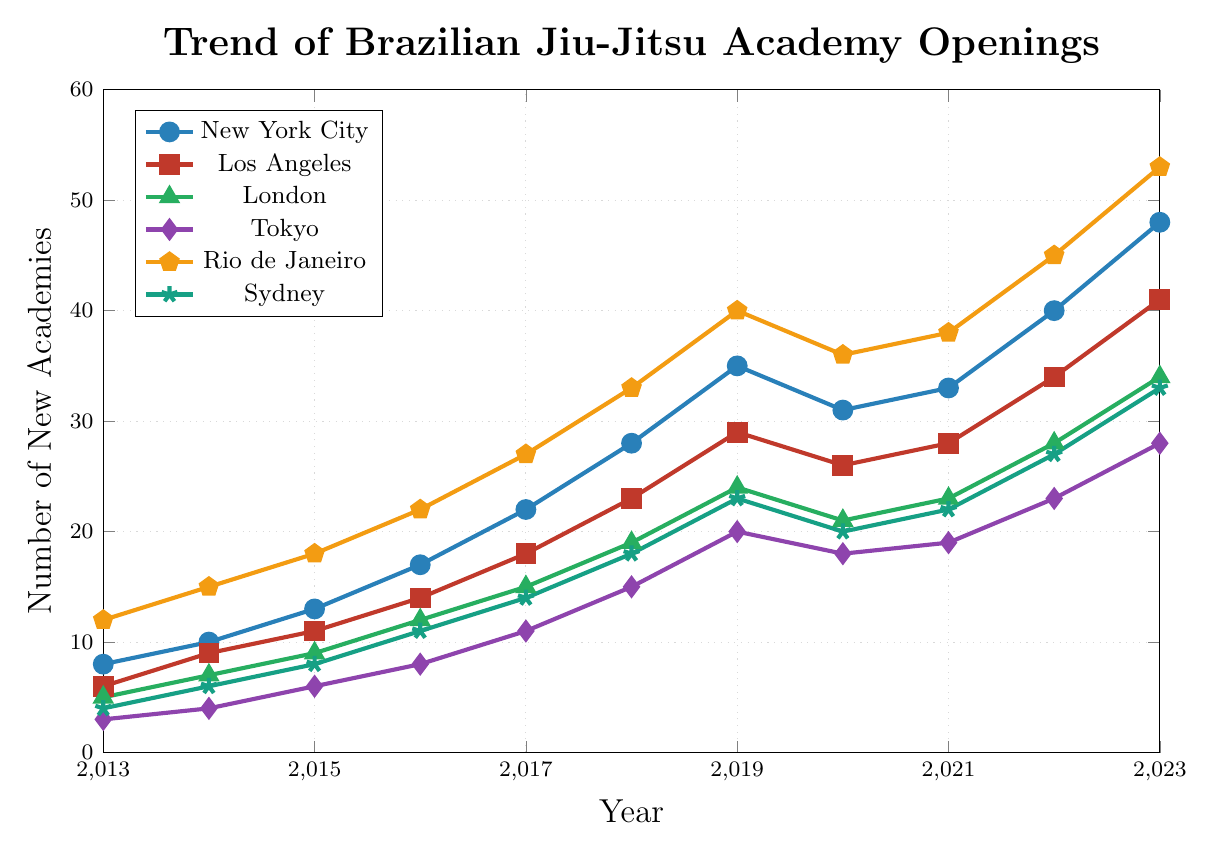Which city saw the highest number of new Brazilian Jiu-Jitsu academies opened in 2023? Look at the highest data point for each city in 2023. Rio de Janeiro has a value of 53 new academies, which is the highest among all the cities.
Answer: Rio de Janeiro Between 2019 and 2020, which city experienced a decrease in the number of new academies? Examine the data points between 2019 and 2020 for each city. New York City, Los Angeles, Tokyo, Rio de Janeiro, and Sydney show a decline.
Answer: New York City, Los Angeles, Tokyo, Rio de Janeiro, Sydney What is the average number of new academies opened in Tokyo from 2013 to 2023? To find the average, sum all the data points for Tokyo from 2013 to 2023 and divide by the number of years. (3+4+6+8+11+15+20+18+19+23+28) / 11 = 155 / 11 = 14.09 (rounded to two decimal places)
Answer: 14.09 Which city had the largest increase in the number of new academies from 2013 to 2023? Calculate the difference between the starting (2013) and ending (2023) values for each city. The largest difference is for Rio de Janeiro with 53 - 12 = 41.
Answer: Rio de Janeiro How many more new academies were opened in Rio de Janeiro compared to Sydney in 2023? Subtract the number of new academies in Sydney from the number in Rio de Janeiro in 2023. 53 - 33 = 20
Answer: 20 In which year did New York City see its sharpest increase in the number of new academies? Compare the year-over-year increments for New York City and identify the year with the highest increase. From 2018 to 2019, the increase was 35 - 28 = 7, which is the sharpest increase.
Answer: 2019 Which two cities had the same number of new academies opened in any given year? Compare the data points for each pair of cities across all years. New York City and Rio de Janeiro both had 36 new academies in 2020.
Answer: New York City and Rio de Janeiro in 2020 What is the total number of new academies opened in Los Angeles from 2013 to 2023? Sum all the data points for Los Angeles from 2013 to 2023. 6 + 9 + 11 + 14 + 18 + 23 + 29 + 26 + 28 + 34 + 41 = 239
Answer: 239 Is there any year where London had fewer new academies than Tokyo? Compare the data points for London and Tokyo for each year. For every year from 2013 to 2023, London had more new academies than Tokyo.
Answer: No By how much did the number of new academies in Sydney increase from 2013 to 2023? Subtract the number of new academies in 2013 from the number in 2023 for Sydney. 33 - 4 = 29
Answer: 29 